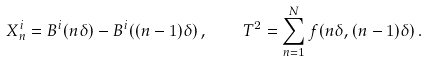Convert formula to latex. <formula><loc_0><loc_0><loc_500><loc_500>X _ { n } ^ { i } = B ^ { i } ( n \delta ) - B ^ { i } ( ( n - 1 ) \delta ) \, , \quad T ^ { 2 } = \sum _ { n = 1 } ^ { N } f ( n \delta , ( n - 1 ) \delta ) \, .</formula> 